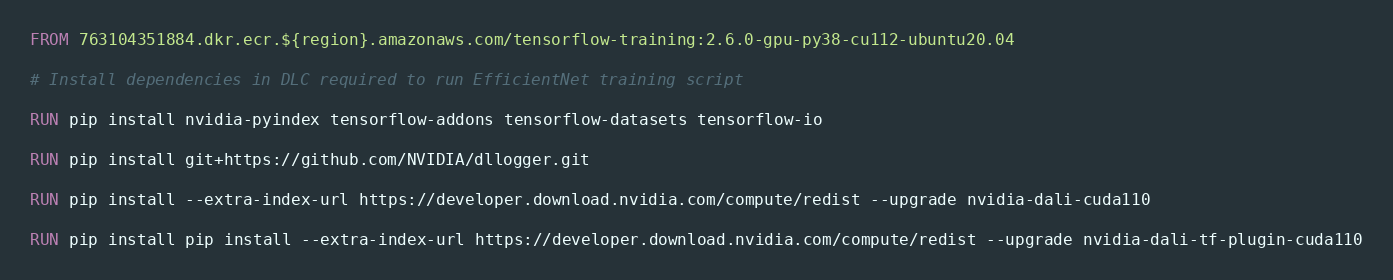Convert code to text. <code><loc_0><loc_0><loc_500><loc_500><_Dockerfile_>FROM 763104351884.dkr.ecr.${region}.amazonaws.com/tensorflow-training:2.6.0-gpu-py38-cu112-ubuntu20.04

# Install dependencies in DLC required to run EfficientNet training script

RUN pip install nvidia-pyindex tensorflow-addons tensorflow-datasets tensorflow-io

RUN pip install git+https://github.com/NVIDIA/dllogger.git

RUN pip install --extra-index-url https://developer.download.nvidia.com/compute/redist --upgrade nvidia-dali-cuda110

RUN pip install pip install --extra-index-url https://developer.download.nvidia.com/compute/redist --upgrade nvidia-dali-tf-plugin-cuda110
</code> 